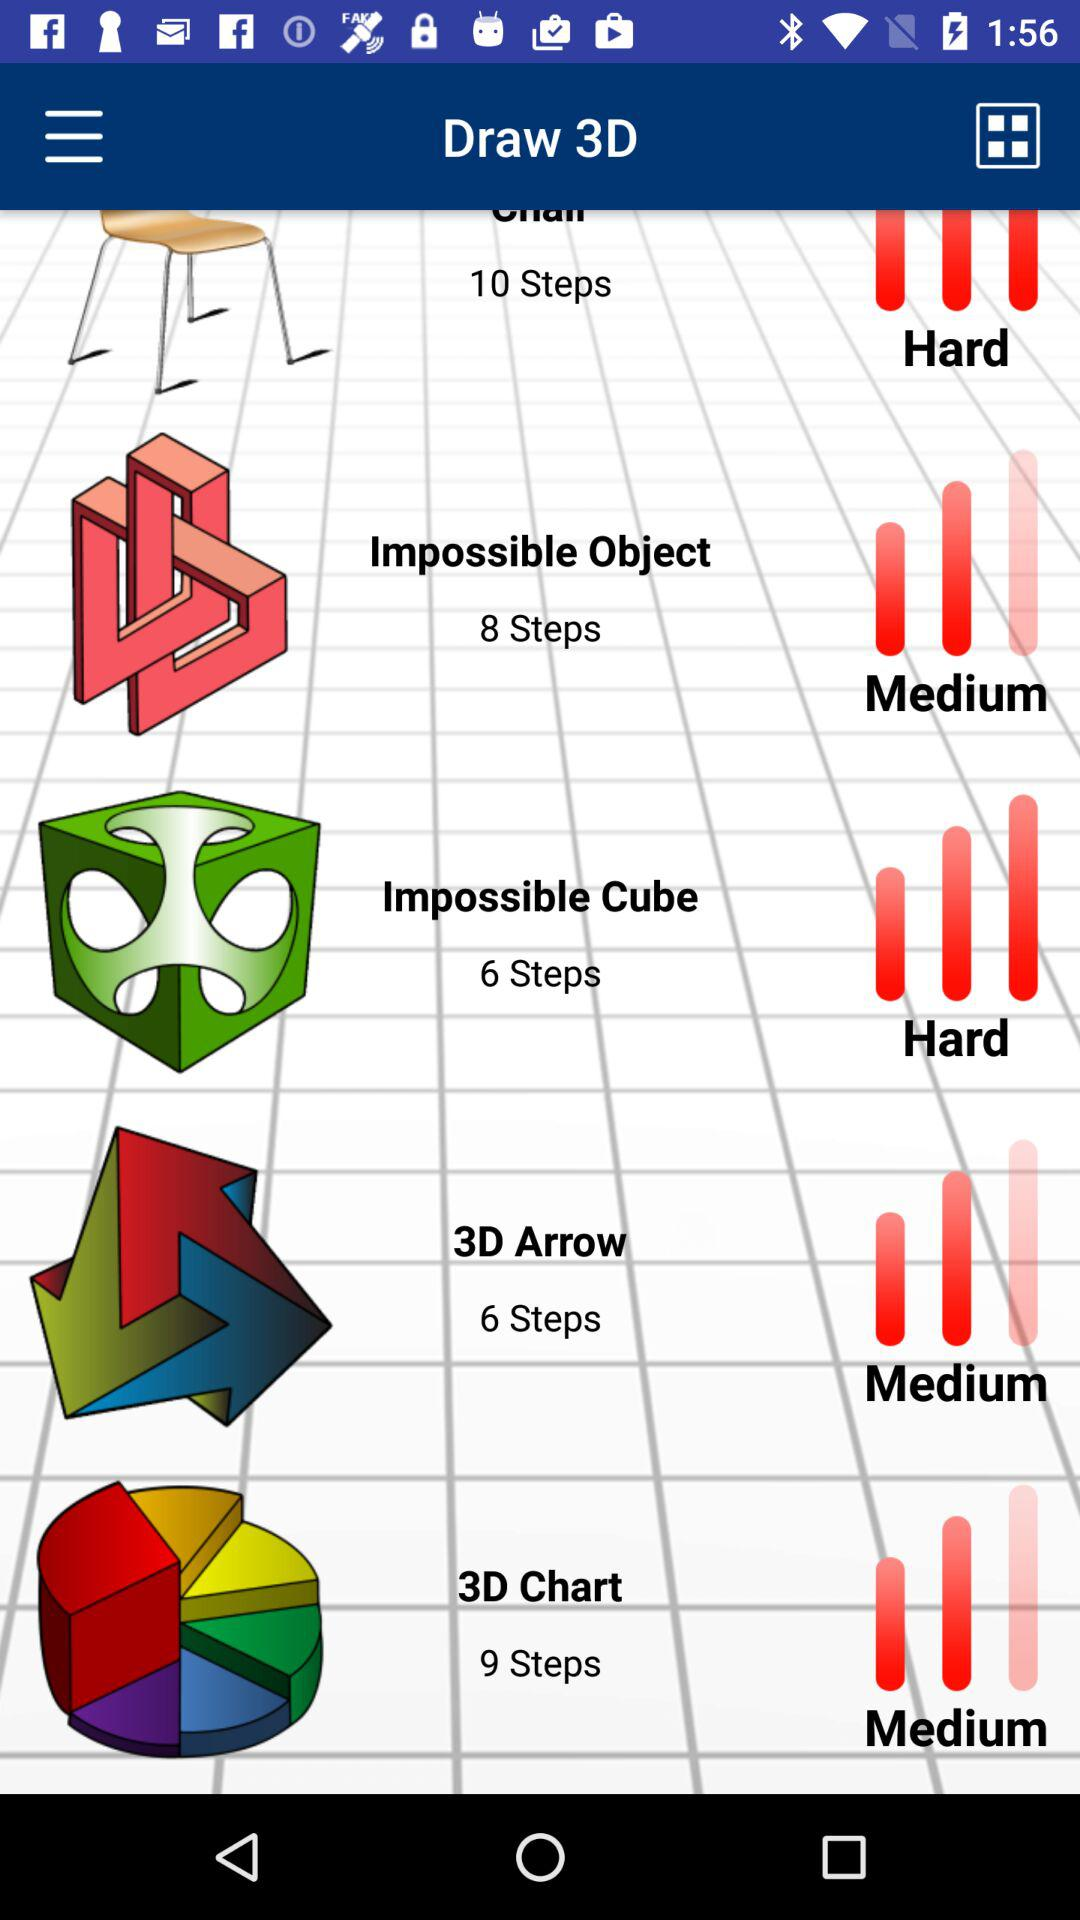What is the number of steps for the "Impossible Cube"? The number of steps for the "Impossible Cube" is 6. 